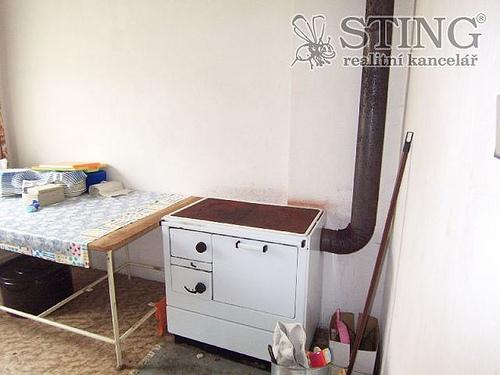Are the appliances modern?
Keep it brief. No. Is the room clean?
Quick response, please. No. Is this a kitchen?
Write a very short answer. Yes. 